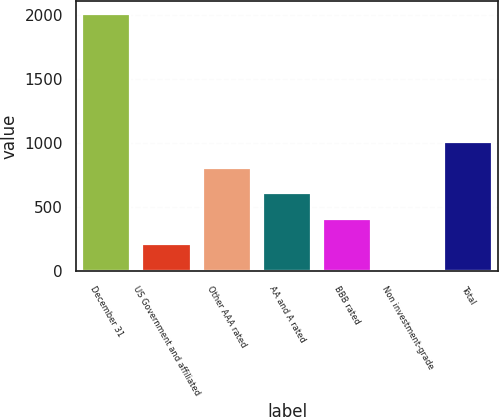<chart> <loc_0><loc_0><loc_500><loc_500><bar_chart><fcel>December 31<fcel>US Government and affiliated<fcel>Other AAA rated<fcel>AA and A rated<fcel>BBB rated<fcel>Non investment-grade<fcel>Total<nl><fcel>2008<fcel>208.81<fcel>808.54<fcel>608.63<fcel>408.72<fcel>8.9<fcel>1008.45<nl></chart> 